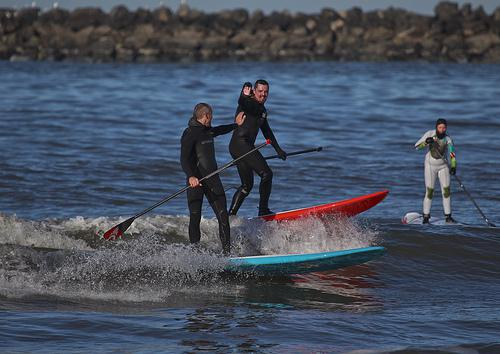Question: who is standing on the rocks?
Choices:
A. No one.
B. A man.
C. A woman.
D. A child.
Answer with the letter. Answer: A Question: why are the people on boards?
Choices:
A. To catch waves.
B. To swim out into the ocean.
C. To ride the waves.
D. Surfing.
Answer with the letter. Answer: D Question: what color board is the man in front riding?
Choices:
A. Blue.
B. Red.
C. Orange.
D. White.
Answer with the letter. Answer: A Question: what color is the water?
Choices:
A. Blue.
B. Green.
C. Gray.
D. Blue green.
Answer with the letter. Answer: A Question: where was this photo taken?
Choices:
A. Near the mountains.
B. On a body of water.
C. By the barn and silos.
D. Next to the cottage.
Answer with the letter. Answer: B 